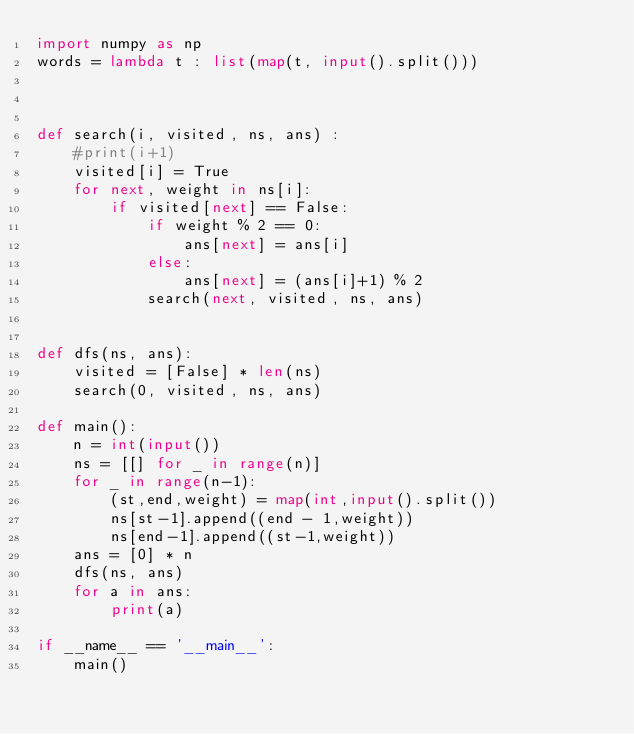<code> <loc_0><loc_0><loc_500><loc_500><_Python_>import numpy as np
words = lambda t : list(map(t, input().split()))



def search(i, visited, ns, ans) :
    #print(i+1)
    visited[i] = True
    for next, weight in ns[i]:
        if visited[next] == False:
            if weight % 2 == 0:
                ans[next] = ans[i]
            else:
                ans[next] = (ans[i]+1) % 2
            search(next, visited, ns, ans)


def dfs(ns, ans):
    visited = [False] * len(ns)
    search(0, visited, ns, ans)

def main():
    n = int(input())
    ns = [[] for _ in range(n)]
    for _ in range(n-1):
        (st,end,weight) = map(int,input().split())
        ns[st-1].append((end - 1,weight))
        ns[end-1].append((st-1,weight))
    ans = [0] * n
    dfs(ns, ans)
    for a in ans:
        print(a)

if __name__ == '__main__':
    main()
</code> 